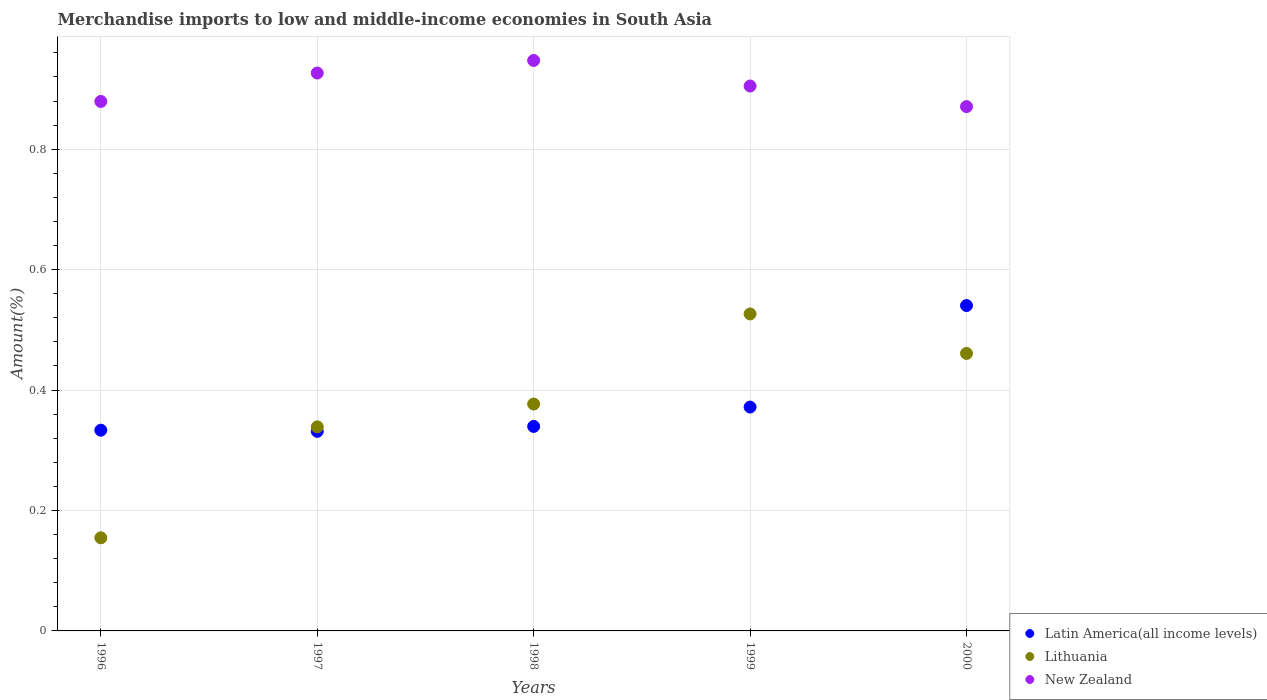How many different coloured dotlines are there?
Provide a succinct answer. 3. Is the number of dotlines equal to the number of legend labels?
Provide a short and direct response. Yes. What is the percentage of amount earned from merchandise imports in Latin America(all income levels) in 1997?
Provide a short and direct response. 0.33. Across all years, what is the maximum percentage of amount earned from merchandise imports in Lithuania?
Make the answer very short. 0.53. Across all years, what is the minimum percentage of amount earned from merchandise imports in Lithuania?
Your response must be concise. 0.15. In which year was the percentage of amount earned from merchandise imports in Latin America(all income levels) maximum?
Keep it short and to the point. 2000. In which year was the percentage of amount earned from merchandise imports in New Zealand minimum?
Provide a succinct answer. 2000. What is the total percentage of amount earned from merchandise imports in Lithuania in the graph?
Ensure brevity in your answer.  1.86. What is the difference between the percentage of amount earned from merchandise imports in Lithuania in 1996 and that in 1998?
Offer a terse response. -0.22. What is the difference between the percentage of amount earned from merchandise imports in Lithuania in 1998 and the percentage of amount earned from merchandise imports in New Zealand in 1999?
Keep it short and to the point. -0.53. What is the average percentage of amount earned from merchandise imports in Lithuania per year?
Give a very brief answer. 0.37. In the year 1998, what is the difference between the percentage of amount earned from merchandise imports in New Zealand and percentage of amount earned from merchandise imports in Latin America(all income levels)?
Provide a short and direct response. 0.61. In how many years, is the percentage of amount earned from merchandise imports in Lithuania greater than 0.16 %?
Give a very brief answer. 4. What is the ratio of the percentage of amount earned from merchandise imports in Latin America(all income levels) in 1999 to that in 2000?
Ensure brevity in your answer.  0.69. Is the difference between the percentage of amount earned from merchandise imports in New Zealand in 1996 and 1999 greater than the difference between the percentage of amount earned from merchandise imports in Latin America(all income levels) in 1996 and 1999?
Your response must be concise. Yes. What is the difference between the highest and the second highest percentage of amount earned from merchandise imports in New Zealand?
Your response must be concise. 0.02. What is the difference between the highest and the lowest percentage of amount earned from merchandise imports in New Zealand?
Make the answer very short. 0.08. In how many years, is the percentage of amount earned from merchandise imports in Lithuania greater than the average percentage of amount earned from merchandise imports in Lithuania taken over all years?
Provide a succinct answer. 3. Is it the case that in every year, the sum of the percentage of amount earned from merchandise imports in Latin America(all income levels) and percentage of amount earned from merchandise imports in New Zealand  is greater than the percentage of amount earned from merchandise imports in Lithuania?
Your answer should be compact. Yes. Does the percentage of amount earned from merchandise imports in New Zealand monotonically increase over the years?
Give a very brief answer. No. Is the percentage of amount earned from merchandise imports in Lithuania strictly less than the percentage of amount earned from merchandise imports in Latin America(all income levels) over the years?
Offer a terse response. No. How many dotlines are there?
Make the answer very short. 3. What is the difference between two consecutive major ticks on the Y-axis?
Provide a succinct answer. 0.2. Are the values on the major ticks of Y-axis written in scientific E-notation?
Ensure brevity in your answer.  No. What is the title of the graph?
Your answer should be very brief. Merchandise imports to low and middle-income economies in South Asia. What is the label or title of the Y-axis?
Your response must be concise. Amount(%). What is the Amount(%) of Latin America(all income levels) in 1996?
Keep it short and to the point. 0.33. What is the Amount(%) of Lithuania in 1996?
Keep it short and to the point. 0.15. What is the Amount(%) in New Zealand in 1996?
Provide a succinct answer. 0.88. What is the Amount(%) of Latin America(all income levels) in 1997?
Keep it short and to the point. 0.33. What is the Amount(%) in Lithuania in 1997?
Give a very brief answer. 0.34. What is the Amount(%) in New Zealand in 1997?
Provide a short and direct response. 0.93. What is the Amount(%) of Latin America(all income levels) in 1998?
Your answer should be compact. 0.34. What is the Amount(%) in Lithuania in 1998?
Your answer should be compact. 0.38. What is the Amount(%) in New Zealand in 1998?
Your answer should be very brief. 0.95. What is the Amount(%) of Latin America(all income levels) in 1999?
Your answer should be very brief. 0.37. What is the Amount(%) in Lithuania in 1999?
Keep it short and to the point. 0.53. What is the Amount(%) in New Zealand in 1999?
Offer a very short reply. 0.9. What is the Amount(%) of Latin America(all income levels) in 2000?
Give a very brief answer. 0.54. What is the Amount(%) in Lithuania in 2000?
Your response must be concise. 0.46. What is the Amount(%) of New Zealand in 2000?
Give a very brief answer. 0.87. Across all years, what is the maximum Amount(%) in Latin America(all income levels)?
Make the answer very short. 0.54. Across all years, what is the maximum Amount(%) of Lithuania?
Keep it short and to the point. 0.53. Across all years, what is the maximum Amount(%) of New Zealand?
Your answer should be compact. 0.95. Across all years, what is the minimum Amount(%) of Latin America(all income levels)?
Give a very brief answer. 0.33. Across all years, what is the minimum Amount(%) in Lithuania?
Provide a succinct answer. 0.15. Across all years, what is the minimum Amount(%) in New Zealand?
Make the answer very short. 0.87. What is the total Amount(%) in Latin America(all income levels) in the graph?
Ensure brevity in your answer.  1.92. What is the total Amount(%) of Lithuania in the graph?
Your answer should be compact. 1.86. What is the total Amount(%) in New Zealand in the graph?
Provide a succinct answer. 4.53. What is the difference between the Amount(%) of Latin America(all income levels) in 1996 and that in 1997?
Make the answer very short. 0. What is the difference between the Amount(%) in Lithuania in 1996 and that in 1997?
Offer a very short reply. -0.18. What is the difference between the Amount(%) of New Zealand in 1996 and that in 1997?
Keep it short and to the point. -0.05. What is the difference between the Amount(%) in Latin America(all income levels) in 1996 and that in 1998?
Ensure brevity in your answer.  -0.01. What is the difference between the Amount(%) in Lithuania in 1996 and that in 1998?
Ensure brevity in your answer.  -0.22. What is the difference between the Amount(%) in New Zealand in 1996 and that in 1998?
Your answer should be very brief. -0.07. What is the difference between the Amount(%) of Latin America(all income levels) in 1996 and that in 1999?
Your answer should be compact. -0.04. What is the difference between the Amount(%) in Lithuania in 1996 and that in 1999?
Your response must be concise. -0.37. What is the difference between the Amount(%) of New Zealand in 1996 and that in 1999?
Your response must be concise. -0.03. What is the difference between the Amount(%) of Latin America(all income levels) in 1996 and that in 2000?
Your answer should be compact. -0.21. What is the difference between the Amount(%) of Lithuania in 1996 and that in 2000?
Make the answer very short. -0.31. What is the difference between the Amount(%) in New Zealand in 1996 and that in 2000?
Ensure brevity in your answer.  0.01. What is the difference between the Amount(%) of Latin America(all income levels) in 1997 and that in 1998?
Ensure brevity in your answer.  -0.01. What is the difference between the Amount(%) in Lithuania in 1997 and that in 1998?
Make the answer very short. -0.04. What is the difference between the Amount(%) of New Zealand in 1997 and that in 1998?
Make the answer very short. -0.02. What is the difference between the Amount(%) in Latin America(all income levels) in 1997 and that in 1999?
Offer a very short reply. -0.04. What is the difference between the Amount(%) in Lithuania in 1997 and that in 1999?
Your response must be concise. -0.19. What is the difference between the Amount(%) of New Zealand in 1997 and that in 1999?
Offer a very short reply. 0.02. What is the difference between the Amount(%) in Latin America(all income levels) in 1997 and that in 2000?
Provide a succinct answer. -0.21. What is the difference between the Amount(%) of Lithuania in 1997 and that in 2000?
Your answer should be very brief. -0.12. What is the difference between the Amount(%) in New Zealand in 1997 and that in 2000?
Provide a succinct answer. 0.06. What is the difference between the Amount(%) in Latin America(all income levels) in 1998 and that in 1999?
Provide a short and direct response. -0.03. What is the difference between the Amount(%) in Lithuania in 1998 and that in 1999?
Give a very brief answer. -0.15. What is the difference between the Amount(%) in New Zealand in 1998 and that in 1999?
Your answer should be compact. 0.04. What is the difference between the Amount(%) of Latin America(all income levels) in 1998 and that in 2000?
Your answer should be very brief. -0.2. What is the difference between the Amount(%) of Lithuania in 1998 and that in 2000?
Keep it short and to the point. -0.08. What is the difference between the Amount(%) in New Zealand in 1998 and that in 2000?
Give a very brief answer. 0.08. What is the difference between the Amount(%) of Latin America(all income levels) in 1999 and that in 2000?
Offer a terse response. -0.17. What is the difference between the Amount(%) of Lithuania in 1999 and that in 2000?
Offer a terse response. 0.07. What is the difference between the Amount(%) in New Zealand in 1999 and that in 2000?
Provide a short and direct response. 0.03. What is the difference between the Amount(%) of Latin America(all income levels) in 1996 and the Amount(%) of Lithuania in 1997?
Your answer should be very brief. -0.01. What is the difference between the Amount(%) of Latin America(all income levels) in 1996 and the Amount(%) of New Zealand in 1997?
Offer a very short reply. -0.59. What is the difference between the Amount(%) of Lithuania in 1996 and the Amount(%) of New Zealand in 1997?
Provide a succinct answer. -0.77. What is the difference between the Amount(%) in Latin America(all income levels) in 1996 and the Amount(%) in Lithuania in 1998?
Give a very brief answer. -0.04. What is the difference between the Amount(%) of Latin America(all income levels) in 1996 and the Amount(%) of New Zealand in 1998?
Provide a short and direct response. -0.61. What is the difference between the Amount(%) in Lithuania in 1996 and the Amount(%) in New Zealand in 1998?
Give a very brief answer. -0.79. What is the difference between the Amount(%) of Latin America(all income levels) in 1996 and the Amount(%) of Lithuania in 1999?
Provide a succinct answer. -0.19. What is the difference between the Amount(%) of Latin America(all income levels) in 1996 and the Amount(%) of New Zealand in 1999?
Your answer should be very brief. -0.57. What is the difference between the Amount(%) of Lithuania in 1996 and the Amount(%) of New Zealand in 1999?
Offer a terse response. -0.75. What is the difference between the Amount(%) in Latin America(all income levels) in 1996 and the Amount(%) in Lithuania in 2000?
Offer a terse response. -0.13. What is the difference between the Amount(%) of Latin America(all income levels) in 1996 and the Amount(%) of New Zealand in 2000?
Provide a short and direct response. -0.54. What is the difference between the Amount(%) in Lithuania in 1996 and the Amount(%) in New Zealand in 2000?
Your answer should be very brief. -0.72. What is the difference between the Amount(%) in Latin America(all income levels) in 1997 and the Amount(%) in Lithuania in 1998?
Offer a very short reply. -0.05. What is the difference between the Amount(%) in Latin America(all income levels) in 1997 and the Amount(%) in New Zealand in 1998?
Offer a terse response. -0.62. What is the difference between the Amount(%) of Lithuania in 1997 and the Amount(%) of New Zealand in 1998?
Offer a terse response. -0.61. What is the difference between the Amount(%) in Latin America(all income levels) in 1997 and the Amount(%) in Lithuania in 1999?
Provide a succinct answer. -0.2. What is the difference between the Amount(%) in Latin America(all income levels) in 1997 and the Amount(%) in New Zealand in 1999?
Keep it short and to the point. -0.57. What is the difference between the Amount(%) in Lithuania in 1997 and the Amount(%) in New Zealand in 1999?
Your answer should be compact. -0.57. What is the difference between the Amount(%) of Latin America(all income levels) in 1997 and the Amount(%) of Lithuania in 2000?
Your answer should be compact. -0.13. What is the difference between the Amount(%) in Latin America(all income levels) in 1997 and the Amount(%) in New Zealand in 2000?
Give a very brief answer. -0.54. What is the difference between the Amount(%) in Lithuania in 1997 and the Amount(%) in New Zealand in 2000?
Your answer should be compact. -0.53. What is the difference between the Amount(%) of Latin America(all income levels) in 1998 and the Amount(%) of Lithuania in 1999?
Your answer should be compact. -0.19. What is the difference between the Amount(%) in Latin America(all income levels) in 1998 and the Amount(%) in New Zealand in 1999?
Provide a succinct answer. -0.57. What is the difference between the Amount(%) of Lithuania in 1998 and the Amount(%) of New Zealand in 1999?
Your answer should be compact. -0.53. What is the difference between the Amount(%) in Latin America(all income levels) in 1998 and the Amount(%) in Lithuania in 2000?
Provide a succinct answer. -0.12. What is the difference between the Amount(%) in Latin America(all income levels) in 1998 and the Amount(%) in New Zealand in 2000?
Your answer should be very brief. -0.53. What is the difference between the Amount(%) of Lithuania in 1998 and the Amount(%) of New Zealand in 2000?
Offer a very short reply. -0.49. What is the difference between the Amount(%) of Latin America(all income levels) in 1999 and the Amount(%) of Lithuania in 2000?
Your response must be concise. -0.09. What is the difference between the Amount(%) of Latin America(all income levels) in 1999 and the Amount(%) of New Zealand in 2000?
Ensure brevity in your answer.  -0.5. What is the difference between the Amount(%) in Lithuania in 1999 and the Amount(%) in New Zealand in 2000?
Offer a terse response. -0.34. What is the average Amount(%) of Latin America(all income levels) per year?
Offer a terse response. 0.38. What is the average Amount(%) in Lithuania per year?
Make the answer very short. 0.37. What is the average Amount(%) in New Zealand per year?
Offer a terse response. 0.91. In the year 1996, what is the difference between the Amount(%) in Latin America(all income levels) and Amount(%) in Lithuania?
Keep it short and to the point. 0.18. In the year 1996, what is the difference between the Amount(%) in Latin America(all income levels) and Amount(%) in New Zealand?
Provide a succinct answer. -0.55. In the year 1996, what is the difference between the Amount(%) in Lithuania and Amount(%) in New Zealand?
Provide a short and direct response. -0.72. In the year 1997, what is the difference between the Amount(%) of Latin America(all income levels) and Amount(%) of Lithuania?
Give a very brief answer. -0.01. In the year 1997, what is the difference between the Amount(%) of Latin America(all income levels) and Amount(%) of New Zealand?
Your answer should be very brief. -0.6. In the year 1997, what is the difference between the Amount(%) of Lithuania and Amount(%) of New Zealand?
Your answer should be very brief. -0.59. In the year 1998, what is the difference between the Amount(%) of Latin America(all income levels) and Amount(%) of Lithuania?
Your answer should be very brief. -0.04. In the year 1998, what is the difference between the Amount(%) in Latin America(all income levels) and Amount(%) in New Zealand?
Make the answer very short. -0.61. In the year 1998, what is the difference between the Amount(%) of Lithuania and Amount(%) of New Zealand?
Provide a short and direct response. -0.57. In the year 1999, what is the difference between the Amount(%) in Latin America(all income levels) and Amount(%) in Lithuania?
Provide a succinct answer. -0.15. In the year 1999, what is the difference between the Amount(%) of Latin America(all income levels) and Amount(%) of New Zealand?
Give a very brief answer. -0.53. In the year 1999, what is the difference between the Amount(%) in Lithuania and Amount(%) in New Zealand?
Provide a succinct answer. -0.38. In the year 2000, what is the difference between the Amount(%) in Latin America(all income levels) and Amount(%) in Lithuania?
Your answer should be compact. 0.08. In the year 2000, what is the difference between the Amount(%) in Latin America(all income levels) and Amount(%) in New Zealand?
Make the answer very short. -0.33. In the year 2000, what is the difference between the Amount(%) in Lithuania and Amount(%) in New Zealand?
Offer a terse response. -0.41. What is the ratio of the Amount(%) in Latin America(all income levels) in 1996 to that in 1997?
Keep it short and to the point. 1.01. What is the ratio of the Amount(%) in Lithuania in 1996 to that in 1997?
Ensure brevity in your answer.  0.46. What is the ratio of the Amount(%) of New Zealand in 1996 to that in 1997?
Keep it short and to the point. 0.95. What is the ratio of the Amount(%) of Latin America(all income levels) in 1996 to that in 1998?
Provide a short and direct response. 0.98. What is the ratio of the Amount(%) in Lithuania in 1996 to that in 1998?
Provide a short and direct response. 0.41. What is the ratio of the Amount(%) of New Zealand in 1996 to that in 1998?
Your answer should be very brief. 0.93. What is the ratio of the Amount(%) of Latin America(all income levels) in 1996 to that in 1999?
Provide a succinct answer. 0.9. What is the ratio of the Amount(%) of Lithuania in 1996 to that in 1999?
Give a very brief answer. 0.29. What is the ratio of the Amount(%) of New Zealand in 1996 to that in 1999?
Your answer should be very brief. 0.97. What is the ratio of the Amount(%) of Latin America(all income levels) in 1996 to that in 2000?
Offer a very short reply. 0.62. What is the ratio of the Amount(%) of Lithuania in 1996 to that in 2000?
Give a very brief answer. 0.34. What is the ratio of the Amount(%) in New Zealand in 1996 to that in 2000?
Make the answer very short. 1.01. What is the ratio of the Amount(%) in Latin America(all income levels) in 1997 to that in 1998?
Your answer should be compact. 0.98. What is the ratio of the Amount(%) of Lithuania in 1997 to that in 1998?
Your response must be concise. 0.9. What is the ratio of the Amount(%) in New Zealand in 1997 to that in 1998?
Offer a very short reply. 0.98. What is the ratio of the Amount(%) in Latin America(all income levels) in 1997 to that in 1999?
Ensure brevity in your answer.  0.89. What is the ratio of the Amount(%) in Lithuania in 1997 to that in 1999?
Your answer should be very brief. 0.64. What is the ratio of the Amount(%) in New Zealand in 1997 to that in 1999?
Ensure brevity in your answer.  1.02. What is the ratio of the Amount(%) in Latin America(all income levels) in 1997 to that in 2000?
Offer a very short reply. 0.61. What is the ratio of the Amount(%) of Lithuania in 1997 to that in 2000?
Offer a very short reply. 0.74. What is the ratio of the Amount(%) of New Zealand in 1997 to that in 2000?
Your response must be concise. 1.06. What is the ratio of the Amount(%) in Latin America(all income levels) in 1998 to that in 1999?
Your answer should be compact. 0.91. What is the ratio of the Amount(%) of Lithuania in 1998 to that in 1999?
Your answer should be compact. 0.72. What is the ratio of the Amount(%) in New Zealand in 1998 to that in 1999?
Keep it short and to the point. 1.05. What is the ratio of the Amount(%) in Latin America(all income levels) in 1998 to that in 2000?
Your answer should be compact. 0.63. What is the ratio of the Amount(%) in Lithuania in 1998 to that in 2000?
Your answer should be compact. 0.82. What is the ratio of the Amount(%) in New Zealand in 1998 to that in 2000?
Provide a succinct answer. 1.09. What is the ratio of the Amount(%) in Latin America(all income levels) in 1999 to that in 2000?
Your answer should be compact. 0.69. What is the ratio of the Amount(%) of Lithuania in 1999 to that in 2000?
Provide a succinct answer. 1.14. What is the ratio of the Amount(%) of New Zealand in 1999 to that in 2000?
Keep it short and to the point. 1.04. What is the difference between the highest and the second highest Amount(%) in Latin America(all income levels)?
Your answer should be compact. 0.17. What is the difference between the highest and the second highest Amount(%) of Lithuania?
Offer a very short reply. 0.07. What is the difference between the highest and the second highest Amount(%) of New Zealand?
Your answer should be very brief. 0.02. What is the difference between the highest and the lowest Amount(%) of Latin America(all income levels)?
Provide a succinct answer. 0.21. What is the difference between the highest and the lowest Amount(%) in Lithuania?
Provide a short and direct response. 0.37. What is the difference between the highest and the lowest Amount(%) of New Zealand?
Ensure brevity in your answer.  0.08. 